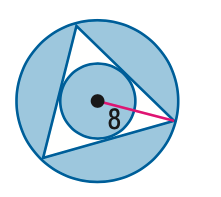Answer the mathemtical geometry problem and directly provide the correct option letter.
Question: Find the area of the shaded region. Assume that all polygons that appear to be regular are regular. Round to the nearest tenth.
Choices: A: 85.1 B: 168.2 C: 203.3 D: 268.7 B 